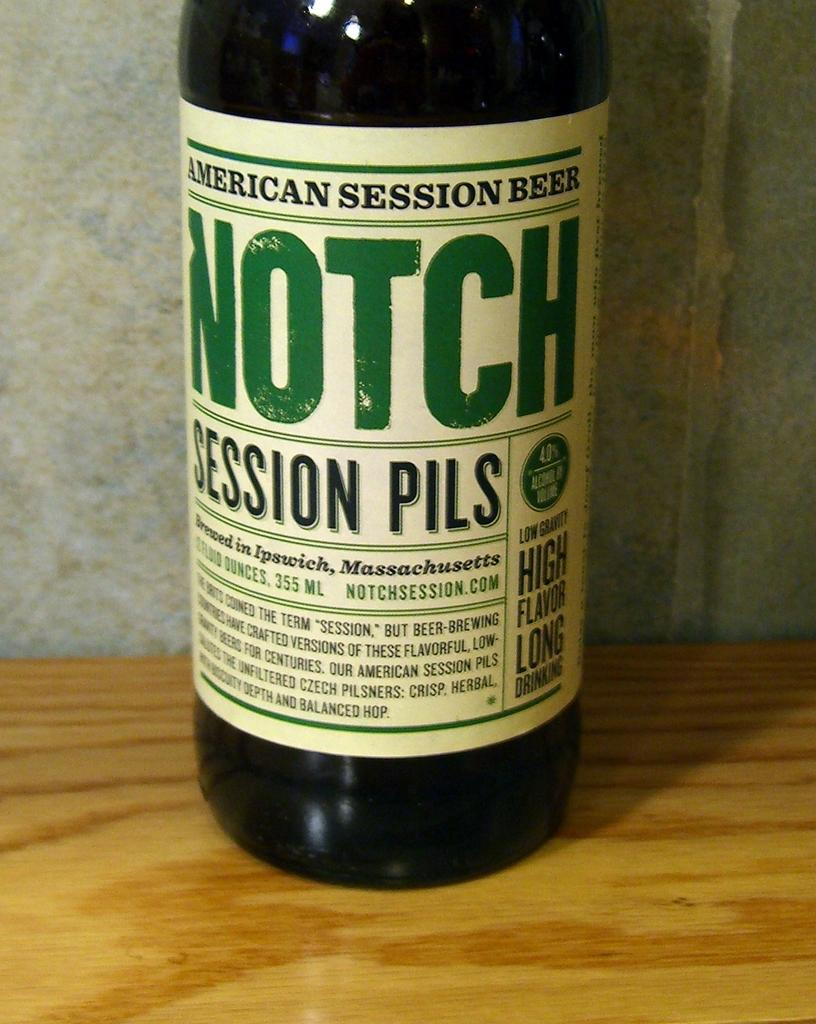Provide a one-sentence caption for the provided image. A bottom of American Session Beer sits on a wooden table. 